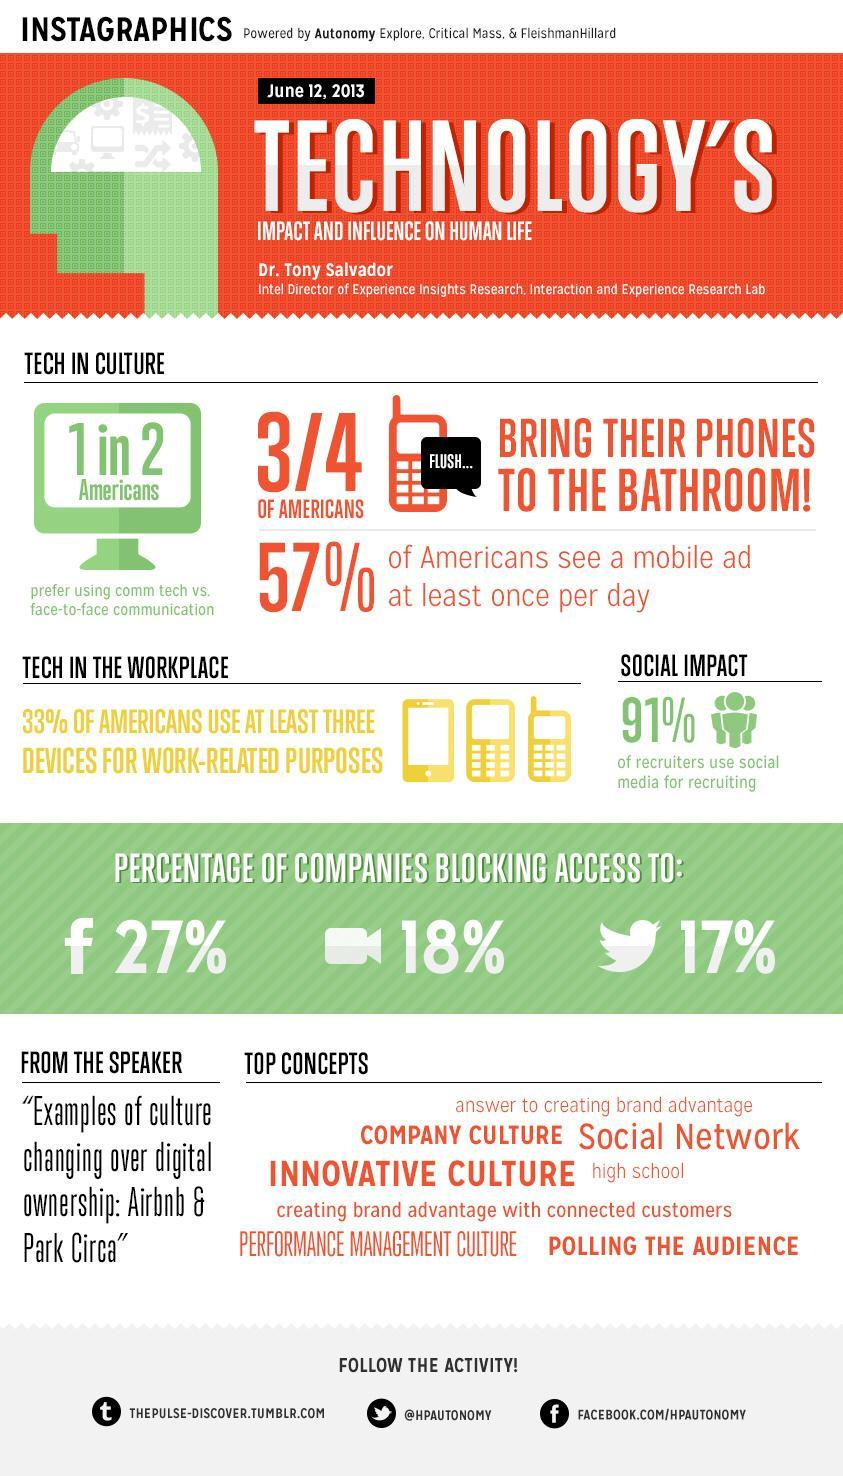What percent of Americans do not see a mobile ad at least once per day?
Answer the question with a short phrase. 43% How many Americans prefer using face-to-face communication vs comm tech? 1 in 2 What percent of recruiters do not prefer social media for recruiting? 9% What is the Twitter handle given? @HPAUTONOMY Which social network is blocked by most companies- Facebook, Twitter or Zoom?? Facebook What percentage of companies are blocking access to Twitter? 17% How many Americans do not bring their ohones to the bathroom? 1/4 